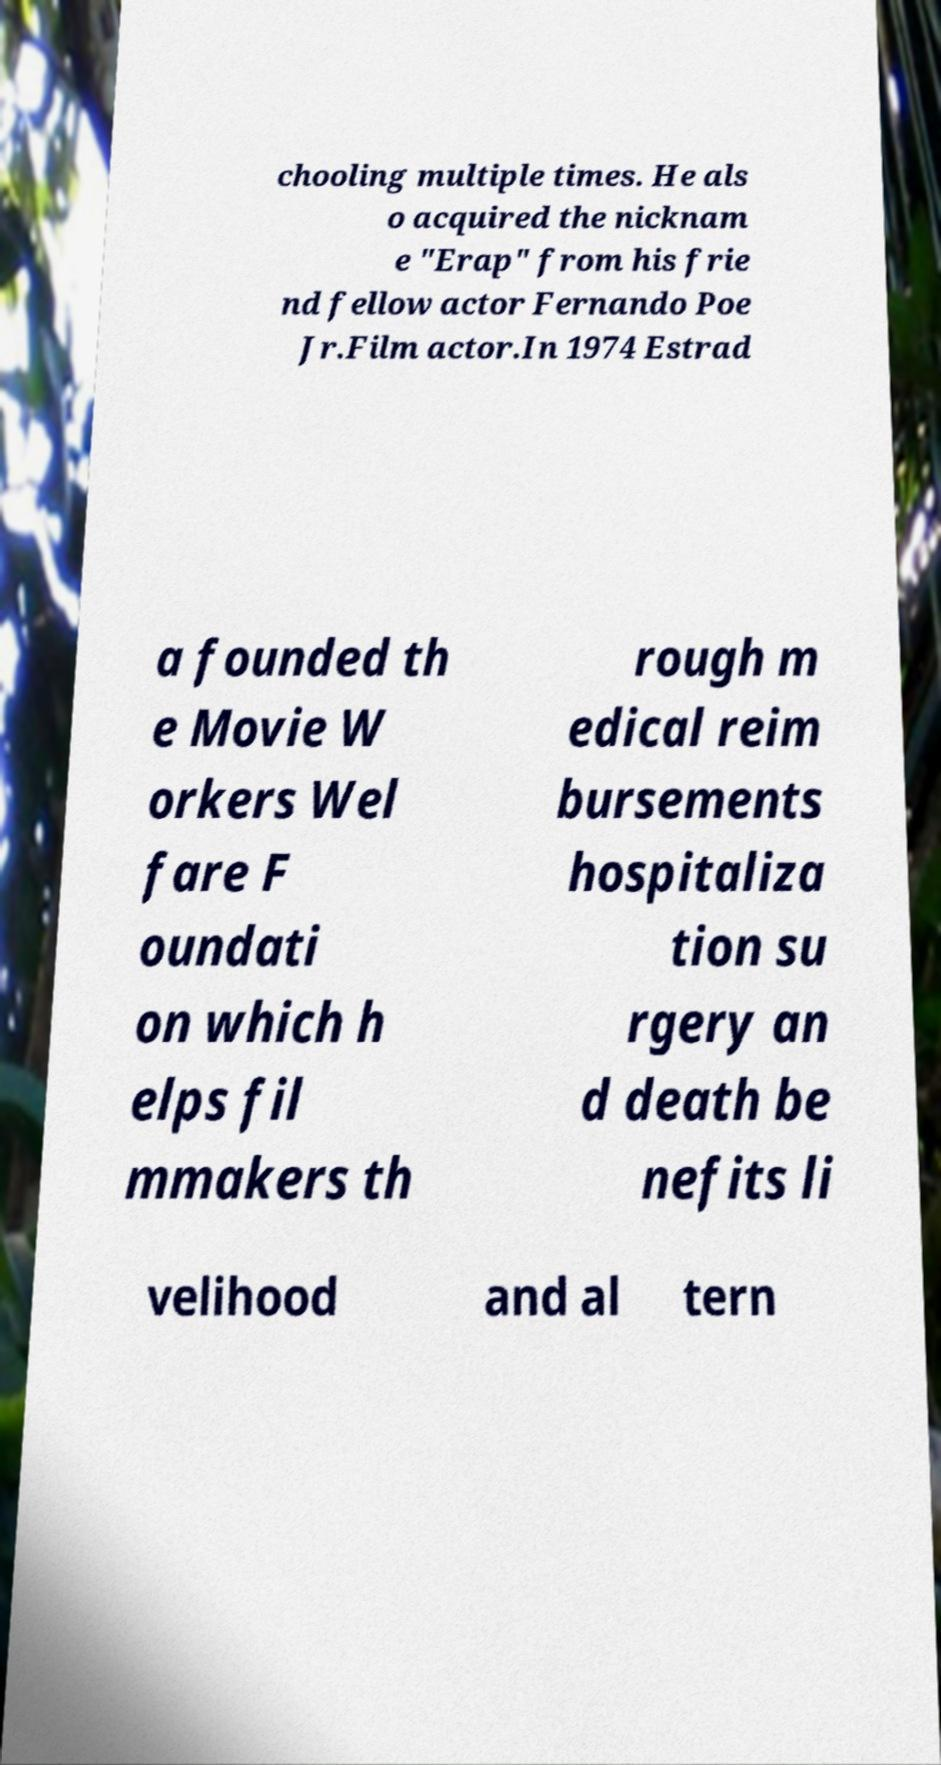There's text embedded in this image that I need extracted. Can you transcribe it verbatim? chooling multiple times. He als o acquired the nicknam e "Erap" from his frie nd fellow actor Fernando Poe Jr.Film actor.In 1974 Estrad a founded th e Movie W orkers Wel fare F oundati on which h elps fil mmakers th rough m edical reim bursements hospitaliza tion su rgery an d death be nefits li velihood and al tern 